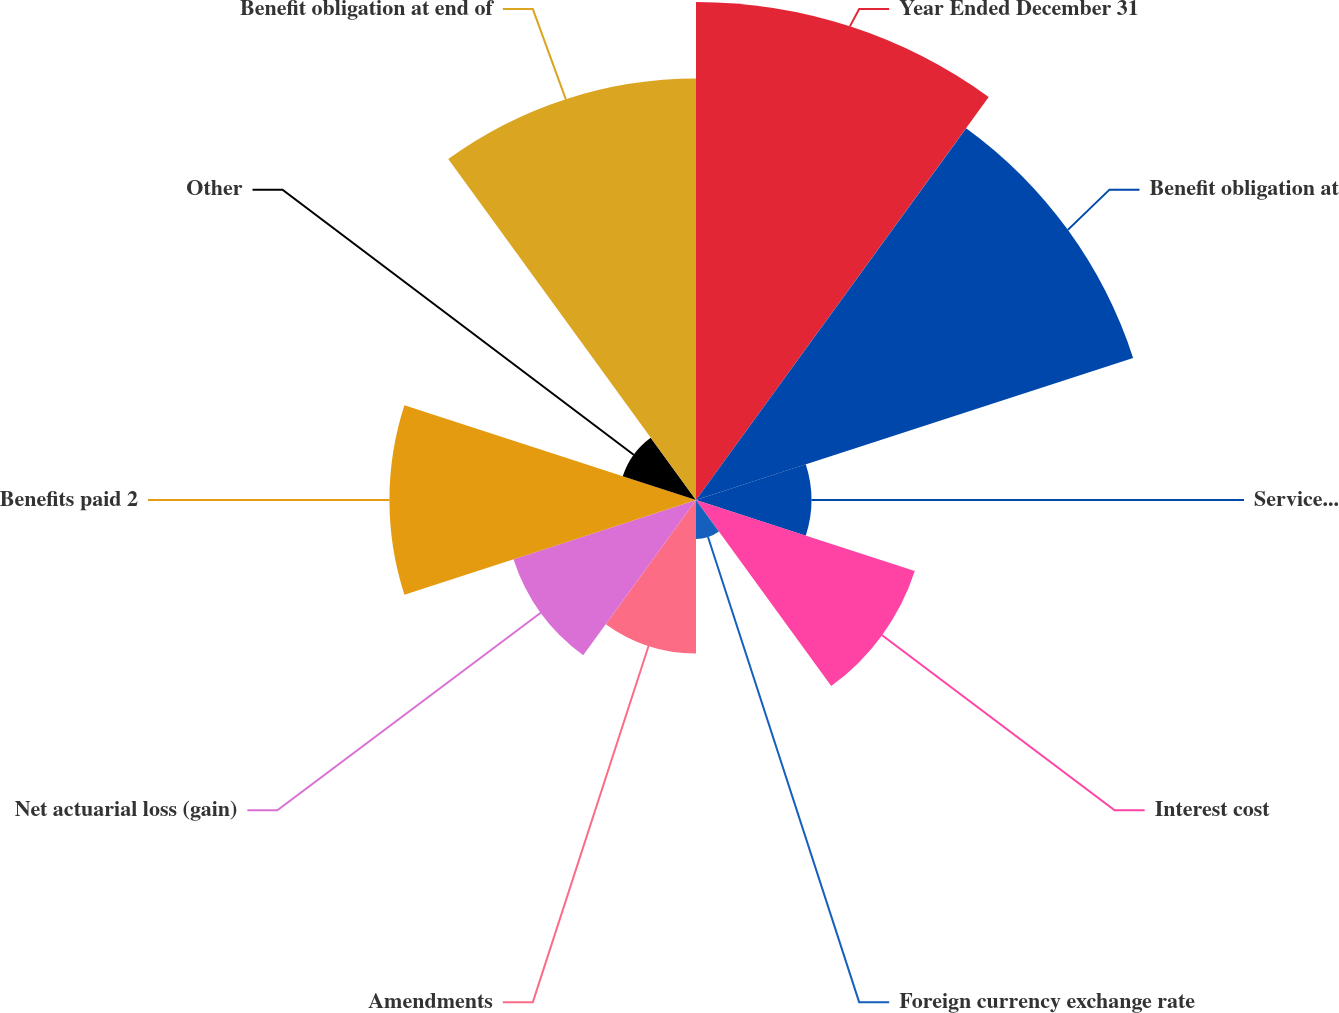<chart> <loc_0><loc_0><loc_500><loc_500><pie_chart><fcel>Year Ended December 31<fcel>Benefit obligation at<fcel>Service cost<fcel>Interest cost<fcel>Foreign currency exchange rate<fcel>Amendments<fcel>Net actuarial loss (gain)<fcel>Benefits paid 2<fcel>Other<fcel>Benefit obligation at end of<nl><fcel>19.98%<fcel>18.44%<fcel>4.63%<fcel>9.23%<fcel>1.56%<fcel>6.16%<fcel>7.7%<fcel>12.3%<fcel>3.09%<fcel>16.91%<nl></chart> 